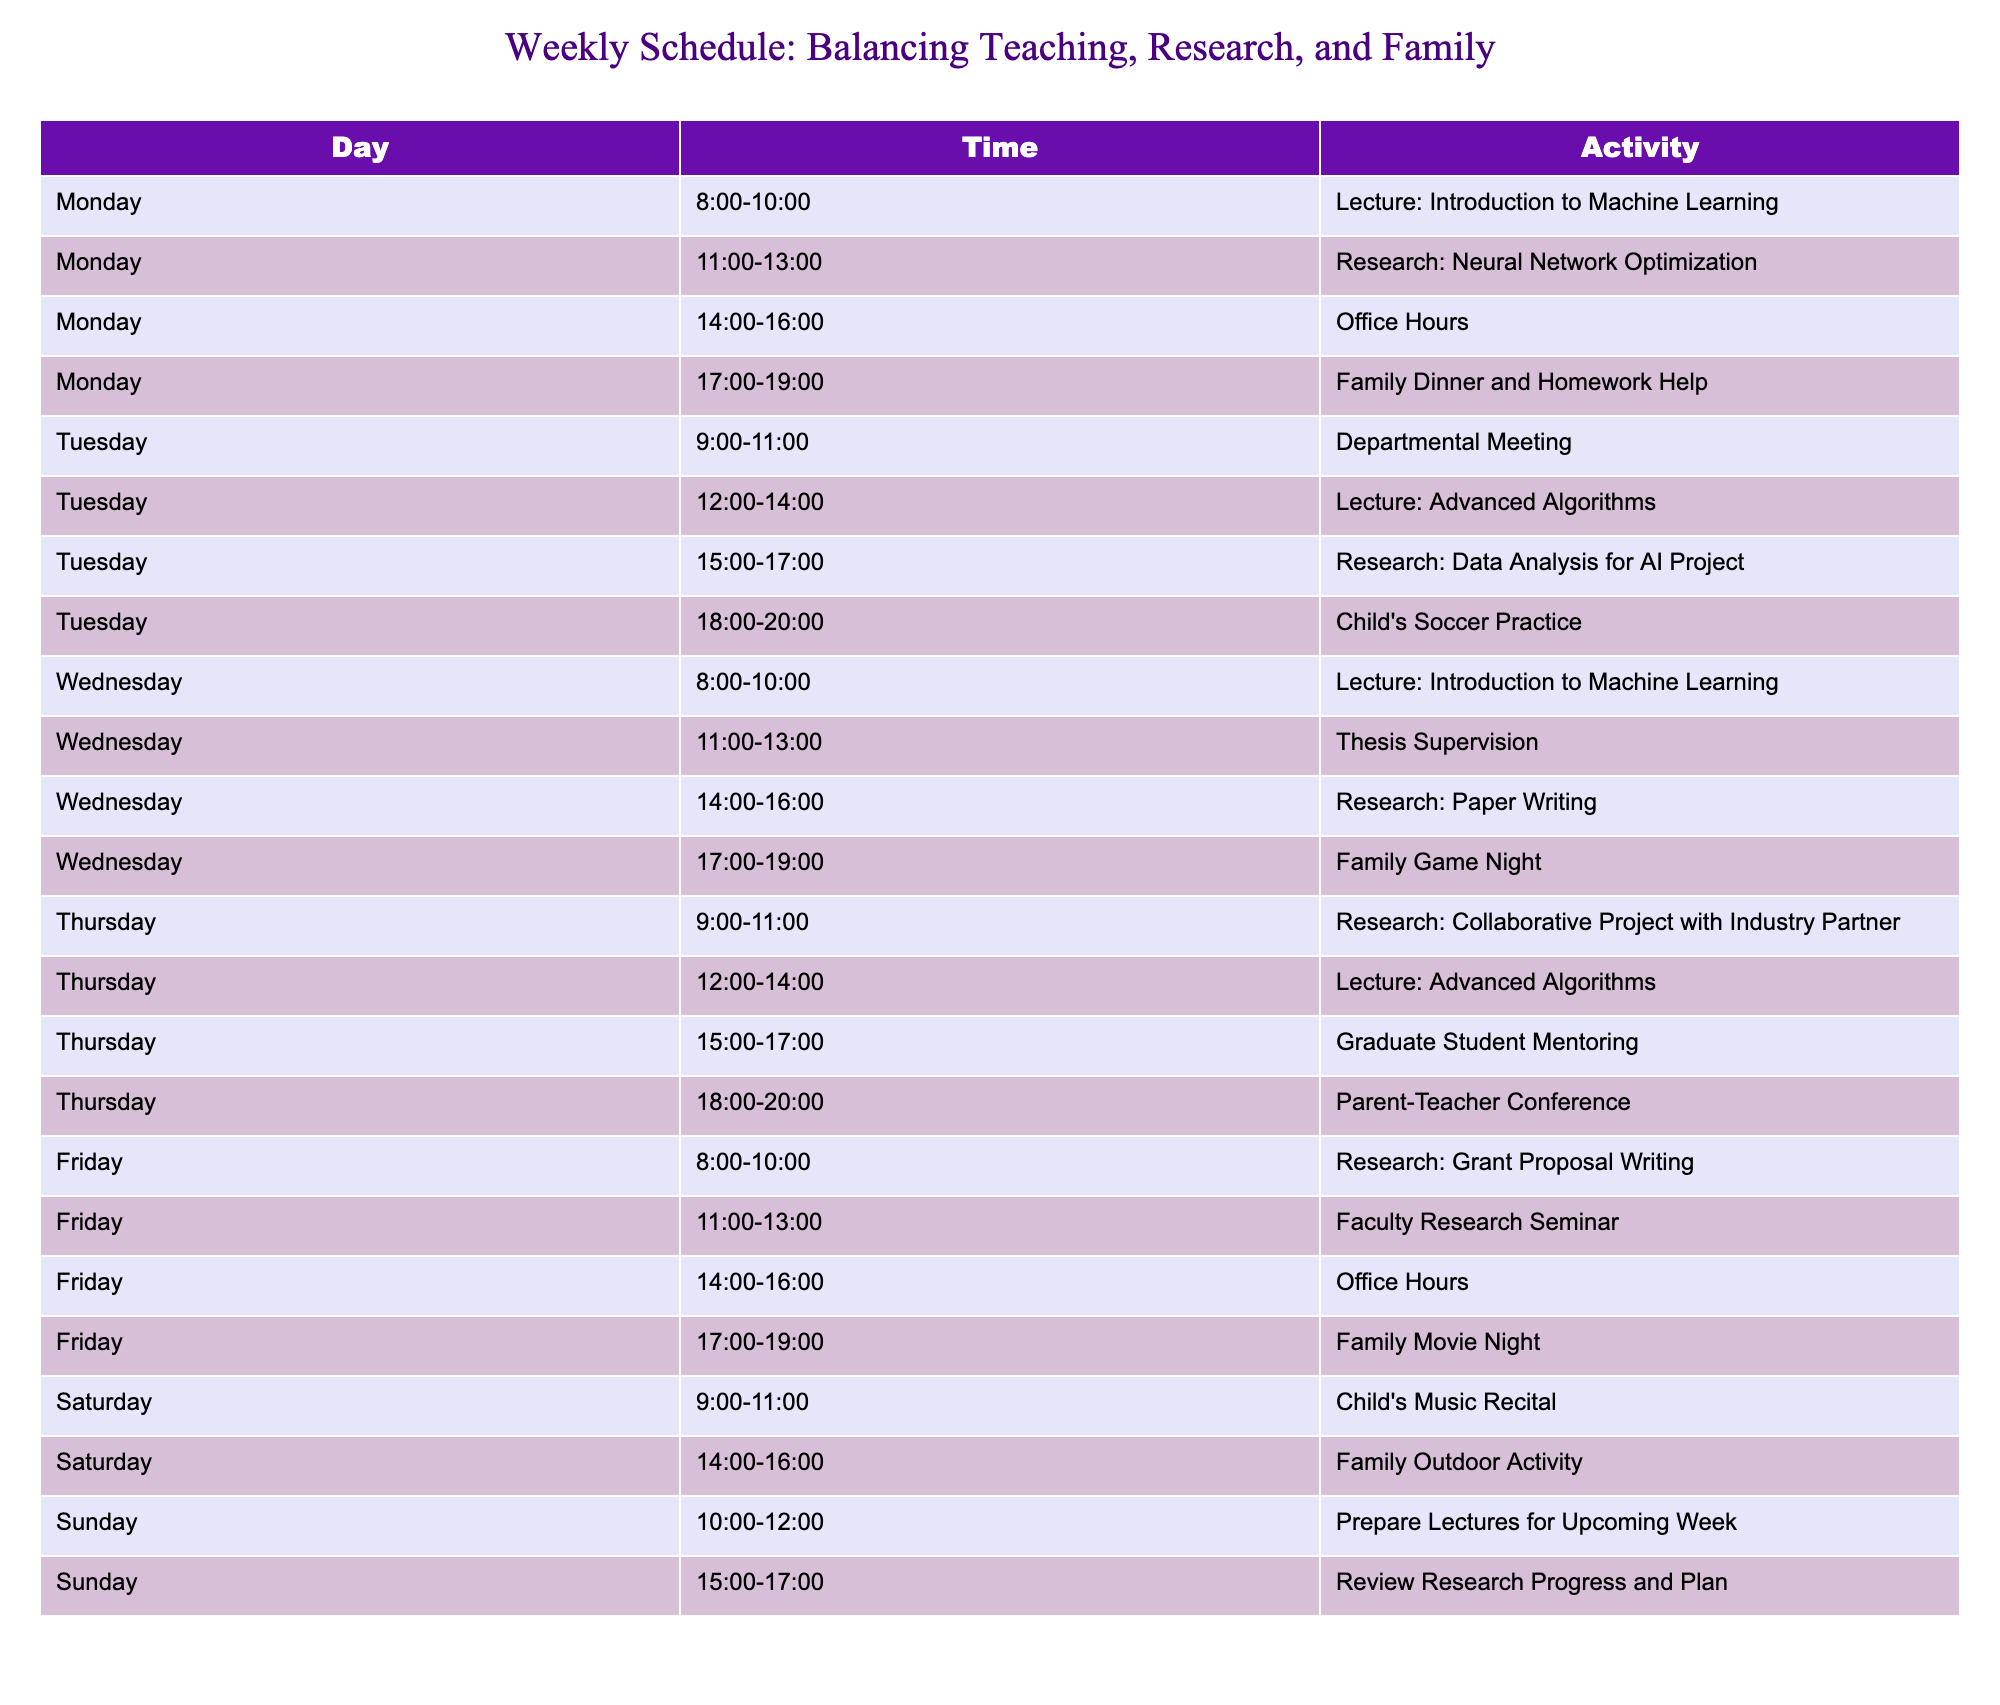What activity is scheduled for Tuesday at 18:00? Referring to the table, I look at Tuesday's row for the 18:00 time slot and see that it is designated for "Child's Soccer Practice."
Answer: Child's Soccer Practice Which day has the most activities scheduled? By reviewing the table for each day, I count the number of activities: Monday has 4, Tuesday has 4, Wednesday has 4, Thursday has 4, Friday has 4, Saturday has 2, and Sunday has 2. The maximum count is 4 activities, which occurs on multiple days.
Answer: Monday, Tuesday, Wednesday, Thursday, Friday True or False: There is no research activity scheduled on Fridays. Checking the Friday row in the table, I find that there is a research activity listed for "Grant Proposal Writing" from 8:00 to 10:00. Therefore, the statement is false.
Answer: False How many lectures are scheduled in total for the week? From the table, I can find the lectures listed: "Introduction to Machine Learning" on Monday and Wednesday (2 lectures), and "Advanced Algorithms" on Tuesday and Thursday (2 lectures). In total, that's 2 + 2 = 4 lectures for the week.
Answer: 4 lectures 